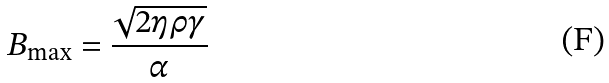Convert formula to latex. <formula><loc_0><loc_0><loc_500><loc_500>B _ { \max } = \frac { \sqrt { 2 \eta \rho \gamma } } { \alpha }</formula> 